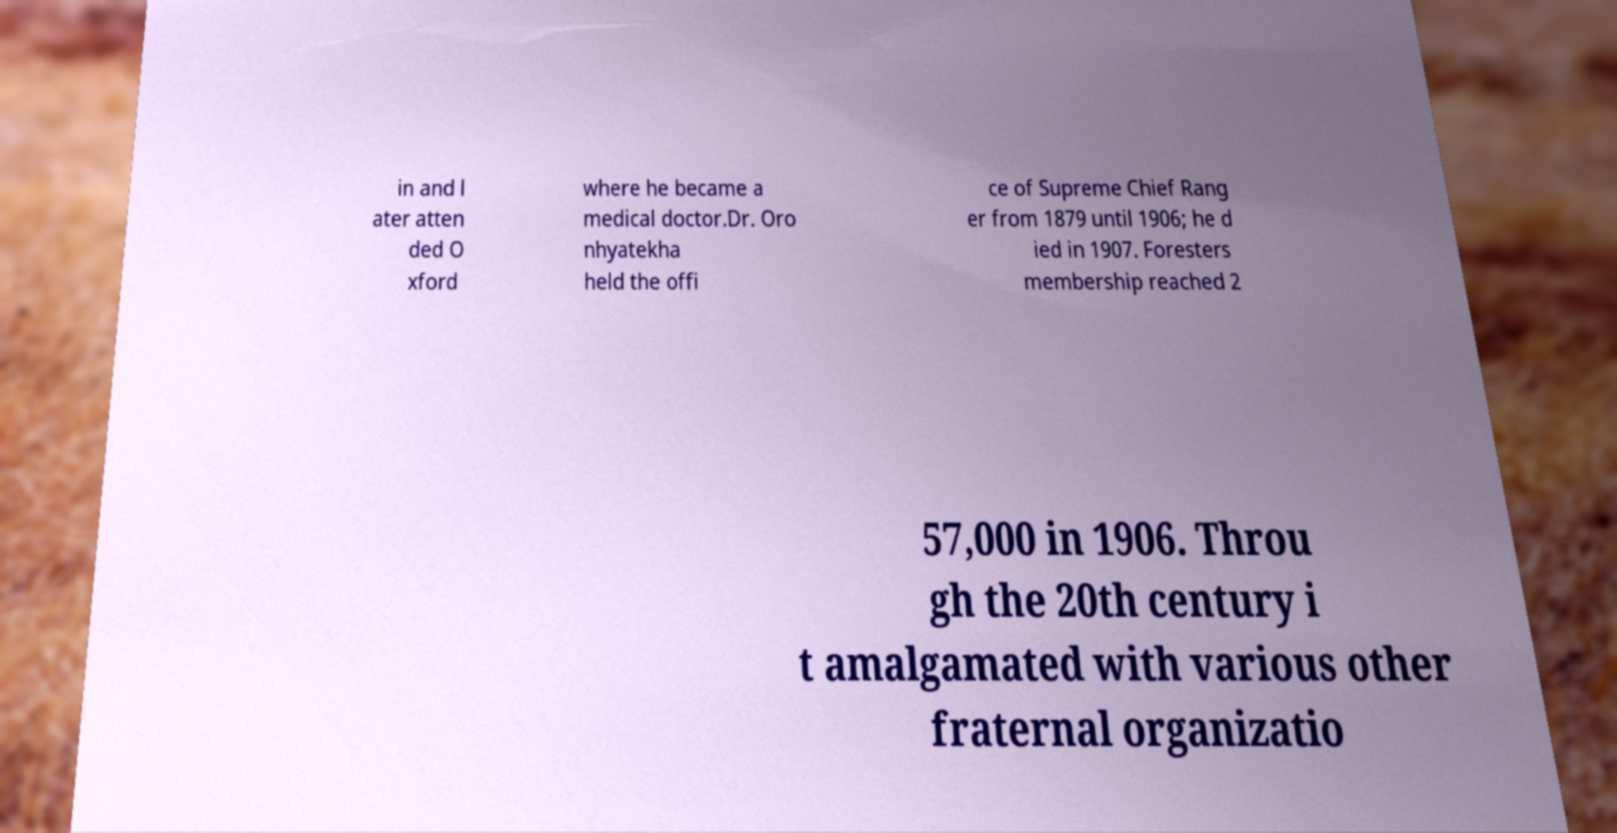What messages or text are displayed in this image? I need them in a readable, typed format. in and l ater atten ded O xford where he became a medical doctor.Dr. Oro nhyatekha held the offi ce of Supreme Chief Rang er from 1879 until 1906; he d ied in 1907. Foresters membership reached 2 57,000 in 1906. Throu gh the 20th century i t amalgamated with various other fraternal organizatio 